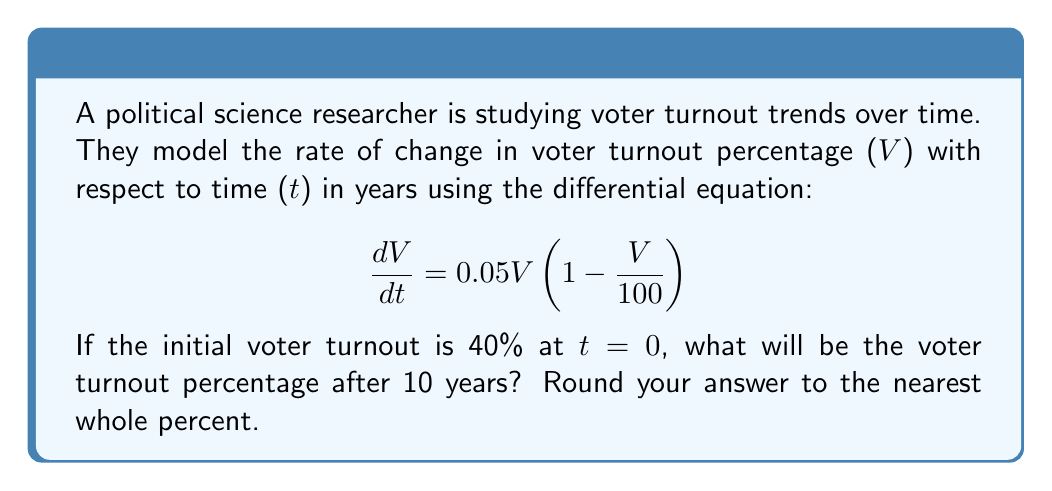Show me your answer to this math problem. To solve this problem, we need to use the logistic growth model, which is a first-order differential equation. Let's approach this step-by-step:

1) The given differential equation is in the form of the logistic growth model:

   $$\frac{dV}{dt} = kV(1 - \frac{V}{M})$$

   where $k = 0.05$ is the growth rate and $M = 100$ is the carrying capacity.

2) The solution to this differential equation is:

   $$V(t) = \frac{M}{1 + (\frac{M}{V_0} - 1)e^{-kt}}$$

   where $V_0$ is the initial value of V.

3) We're given that $V_0 = 40$, $M = 100$, $k = 0.05$, and we want to find $V(10)$.

4) Substituting these values into the solution:

   $$V(10) = \frac{100}{1 + (\frac{100}{40} - 1)e^{-0.05(10)}}$$

5) Simplify:
   
   $$V(10) = \frac{100}{1 + 1.5e^{-0.5}}$$

6) Calculate:
   
   $$V(10) = \frac{100}{1 + 1.5(0.6065)} = \frac{100}{1.9098} = 52.36$$

7) Rounding to the nearest whole percent:

   $V(10) \approx 52\%$
Answer: 52% 